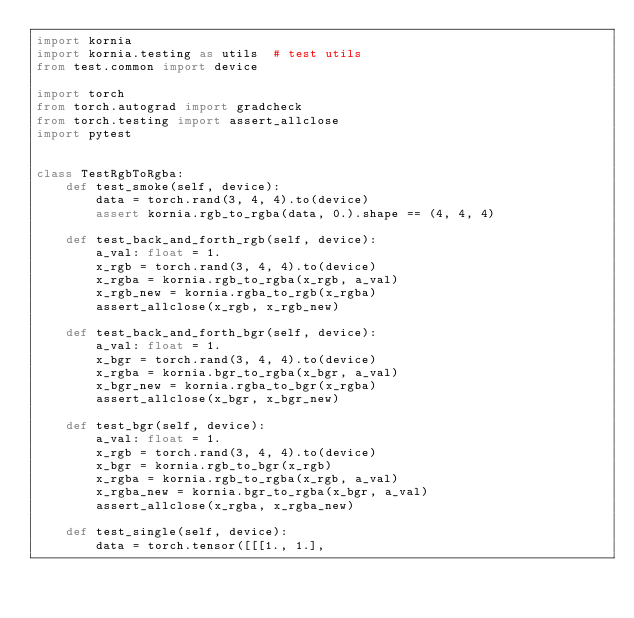Convert code to text. <code><loc_0><loc_0><loc_500><loc_500><_Python_>import kornia
import kornia.testing as utils  # test utils
from test.common import device

import torch
from torch.autograd import gradcheck
from torch.testing import assert_allclose
import pytest


class TestRgbToRgba:
    def test_smoke(self, device):
        data = torch.rand(3, 4, 4).to(device)
        assert kornia.rgb_to_rgba(data, 0.).shape == (4, 4, 4)

    def test_back_and_forth_rgb(self, device):
        a_val: float = 1.
        x_rgb = torch.rand(3, 4, 4).to(device)
        x_rgba = kornia.rgb_to_rgba(x_rgb, a_val)
        x_rgb_new = kornia.rgba_to_rgb(x_rgba)
        assert_allclose(x_rgb, x_rgb_new)

    def test_back_and_forth_bgr(self, device):
        a_val: float = 1.
        x_bgr = torch.rand(3, 4, 4).to(device)
        x_rgba = kornia.bgr_to_rgba(x_bgr, a_val)
        x_bgr_new = kornia.rgba_to_bgr(x_rgba)
        assert_allclose(x_bgr, x_bgr_new)

    def test_bgr(self, device):
        a_val: float = 1.
        x_rgb = torch.rand(3, 4, 4).to(device)
        x_bgr = kornia.rgb_to_bgr(x_rgb)
        x_rgba = kornia.rgb_to_rgba(x_rgb, a_val)
        x_rgba_new = kornia.bgr_to_rgba(x_bgr, a_val)
        assert_allclose(x_rgba, x_rgba_new)

    def test_single(self, device):
        data = torch.tensor([[[1., 1.],</code> 